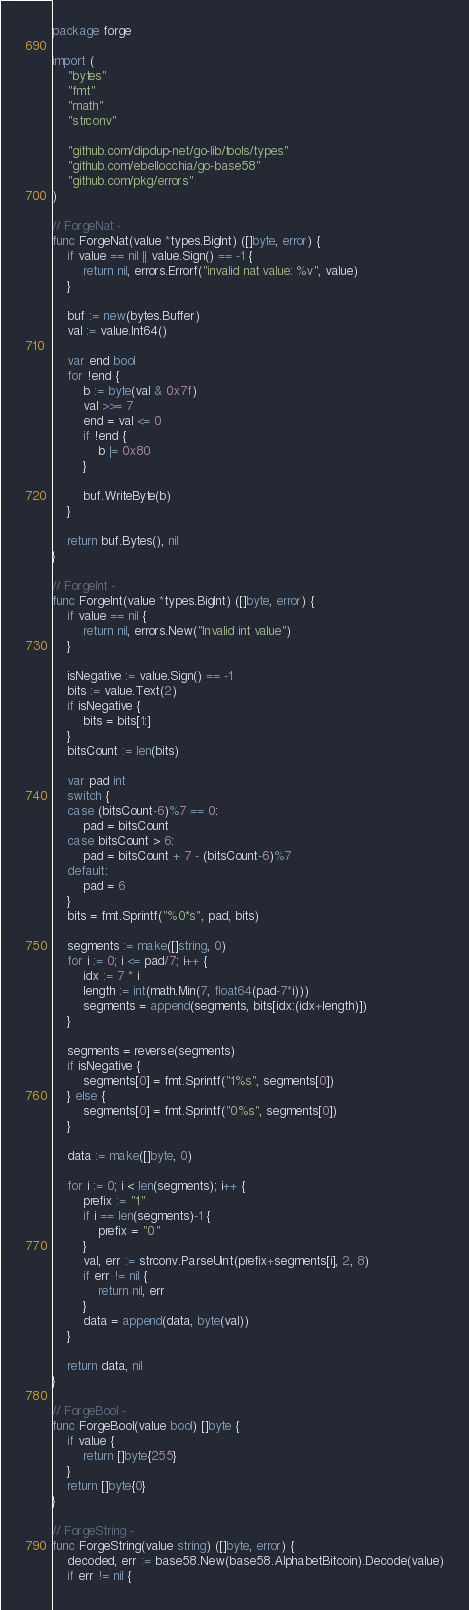<code> <loc_0><loc_0><loc_500><loc_500><_Go_>package forge

import (
	"bytes"
	"fmt"
	"math"
	"strconv"

	"github.com/dipdup-net/go-lib/tools/types"
	"github.com/ebellocchia/go-base58"
	"github.com/pkg/errors"
)

// ForgeNat -
func ForgeNat(value *types.BigInt) ([]byte, error) {
	if value == nil || value.Sign() == -1 {
		return nil, errors.Errorf("invalid nat value: %v", value)
	}

	buf := new(bytes.Buffer)
	val := value.Int64()

	var end bool
	for !end {
		b := byte(val & 0x7f)
		val >>= 7
		end = val <= 0
		if !end {
			b |= 0x80
		}

		buf.WriteByte(b)
	}

	return buf.Bytes(), nil
}

// ForgeInt -
func ForgeInt(value *types.BigInt) ([]byte, error) {
	if value == nil {
		return nil, errors.New("Invalid int value")
	}

	isNegative := value.Sign() == -1
	bits := value.Text(2)
	if isNegative {
		bits = bits[1:]
	}
	bitsCount := len(bits)

	var pad int
	switch {
	case (bitsCount-6)%7 == 0:
		pad = bitsCount
	case bitsCount > 6:
		pad = bitsCount + 7 - (bitsCount-6)%7
	default:
		pad = 6
	}
	bits = fmt.Sprintf("%0*s", pad, bits)

	segments := make([]string, 0)
	for i := 0; i <= pad/7; i++ {
		idx := 7 * i
		length := int(math.Min(7, float64(pad-7*i)))
		segments = append(segments, bits[idx:(idx+length)])
	}

	segments = reverse(segments)
	if isNegative {
		segments[0] = fmt.Sprintf("1%s", segments[0])
	} else {
		segments[0] = fmt.Sprintf("0%s", segments[0])
	}

	data := make([]byte, 0)

	for i := 0; i < len(segments); i++ {
		prefix := "1"
		if i == len(segments)-1 {
			prefix = "0"
		}
		val, err := strconv.ParseUint(prefix+segments[i], 2, 8)
		if err != nil {
			return nil, err
		}
		data = append(data, byte(val))
	}

	return data, nil
}

// ForgeBool -
func ForgeBool(value bool) []byte {
	if value {
		return []byte{255}
	}
	return []byte{0}
}

// ForgeString -
func ForgeString(value string) ([]byte, error) {
	decoded, err := base58.New(base58.AlphabetBitcoin).Decode(value)
	if err != nil {</code> 